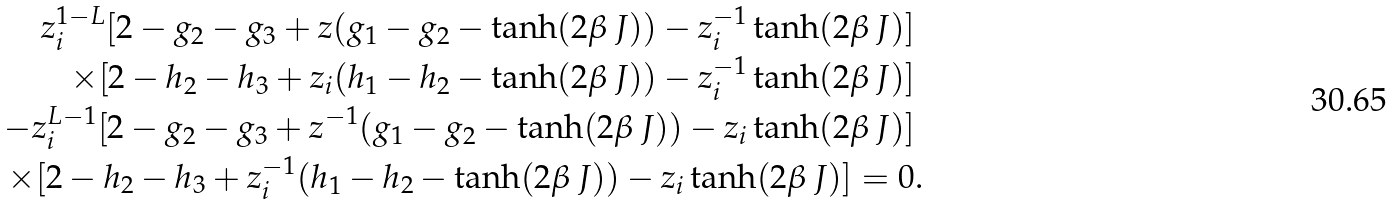Convert formula to latex. <formula><loc_0><loc_0><loc_500><loc_500>z _ { i } ^ { 1 - L } [ 2 - g _ { 2 } - g _ { 3 } + z ( g _ { 1 } - g _ { 2 } - \tanh ( 2 \beta \, J ) ) - z _ { i } ^ { - 1 } \tanh ( 2 \beta \, J ) ] & \\ \times [ 2 - h _ { 2 } - h _ { 3 } + z _ { i } ( h _ { 1 } - h _ { 2 } - \tanh ( 2 \beta \, J ) ) - z _ { i } ^ { - 1 } \tanh ( 2 \beta \, J ) ] & \\ - z _ { i } ^ { L - 1 } [ 2 - g _ { 2 } - g _ { 3 } + z ^ { - 1 } ( g _ { 1 } - g _ { 2 } - \tanh ( 2 \beta \, J ) ) - z _ { i } \tanh ( 2 \beta \, J ) ] & \\ \times [ 2 - h _ { 2 } - h _ { 3 } + z _ { i } ^ { - 1 } ( h _ { 1 } - h _ { 2 } - \tanh ( 2 \beta \, J ) ) - z _ { i } \tanh ( 2 \beta \, J ) ] = 0 & .</formula> 